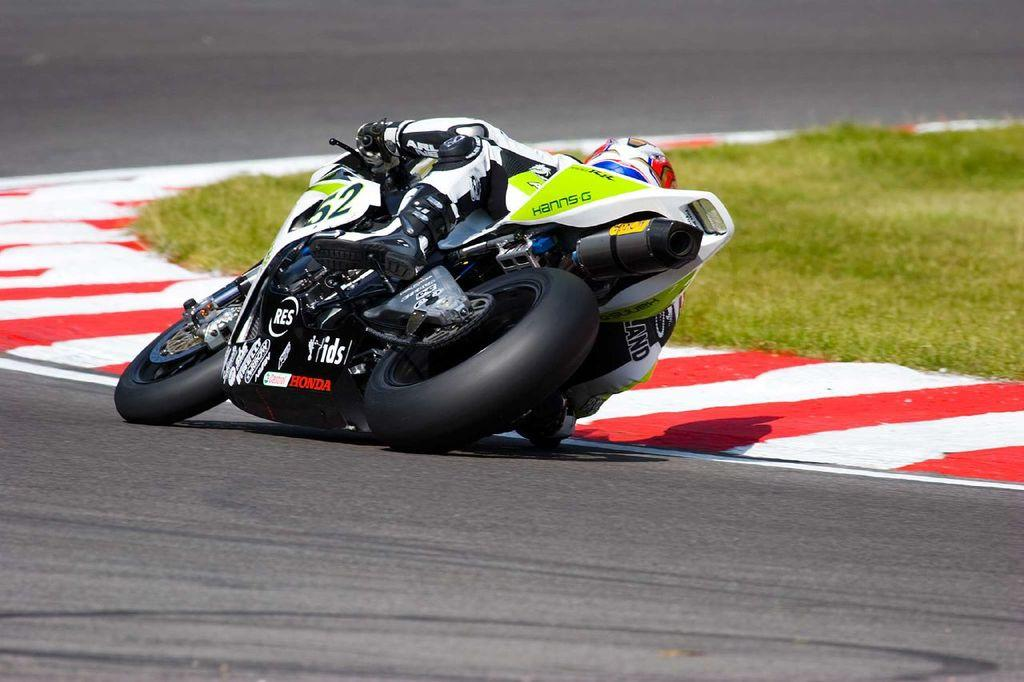What is the main subject of the image? There is a person riding a motorcycle in the image. Where is the motorcycle located? The motorcycle is on the road. What type of vegetation can be seen in the image? There is grass visible at the right side of the image. What type of drug can be seen in the image? There is no drug present in the image. What muscle is the person flexing while riding the motorcycle? The image does not show the person flexing any muscles. 